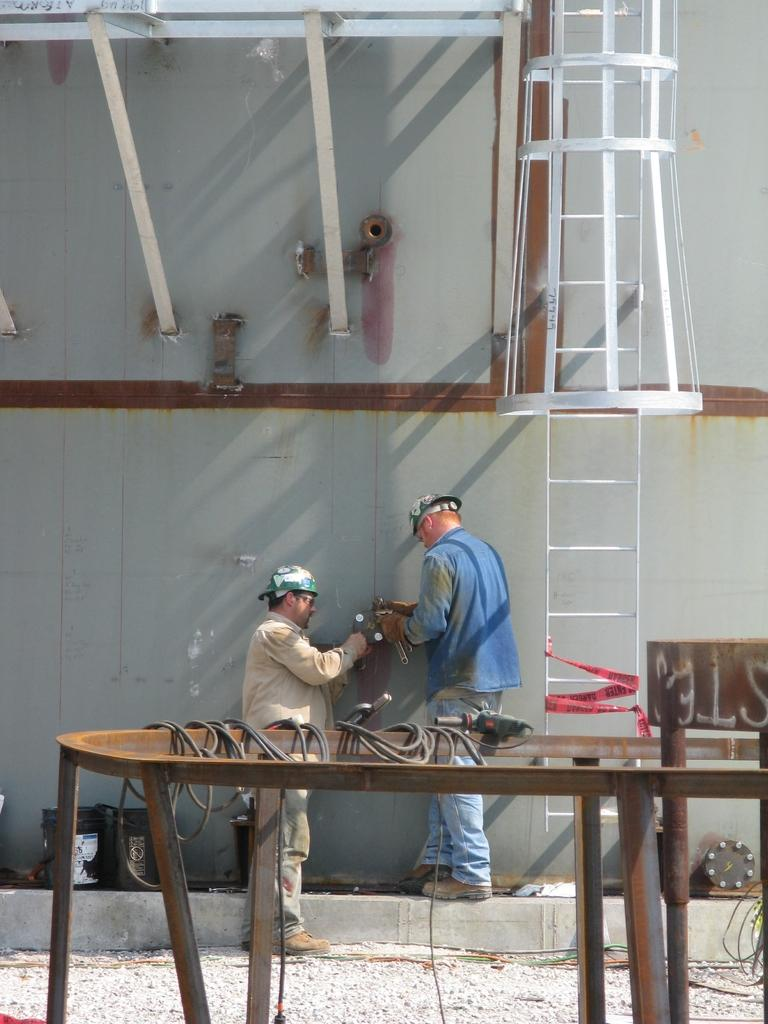How many people are present in the image? There are two persons standing in the image. What can be seen on the right side of the image? There is a ladder on the right side of the image. What type of bread can be seen waving in the wind in the image? There is no bread present in the image, nor is there any waving motion or wind depicted. 